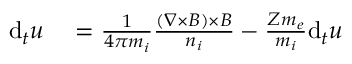<formula> <loc_0><loc_0><loc_500><loc_500>\begin{array} { r l } { d _ { t } u } & = \frac { 1 } { 4 \pi m _ { i } } \frac { ( \nabla \times B ) \times B } { n _ { i } } - \frac { Z m _ { e } } { m _ { i } } d _ { t } u } \end{array}</formula> 